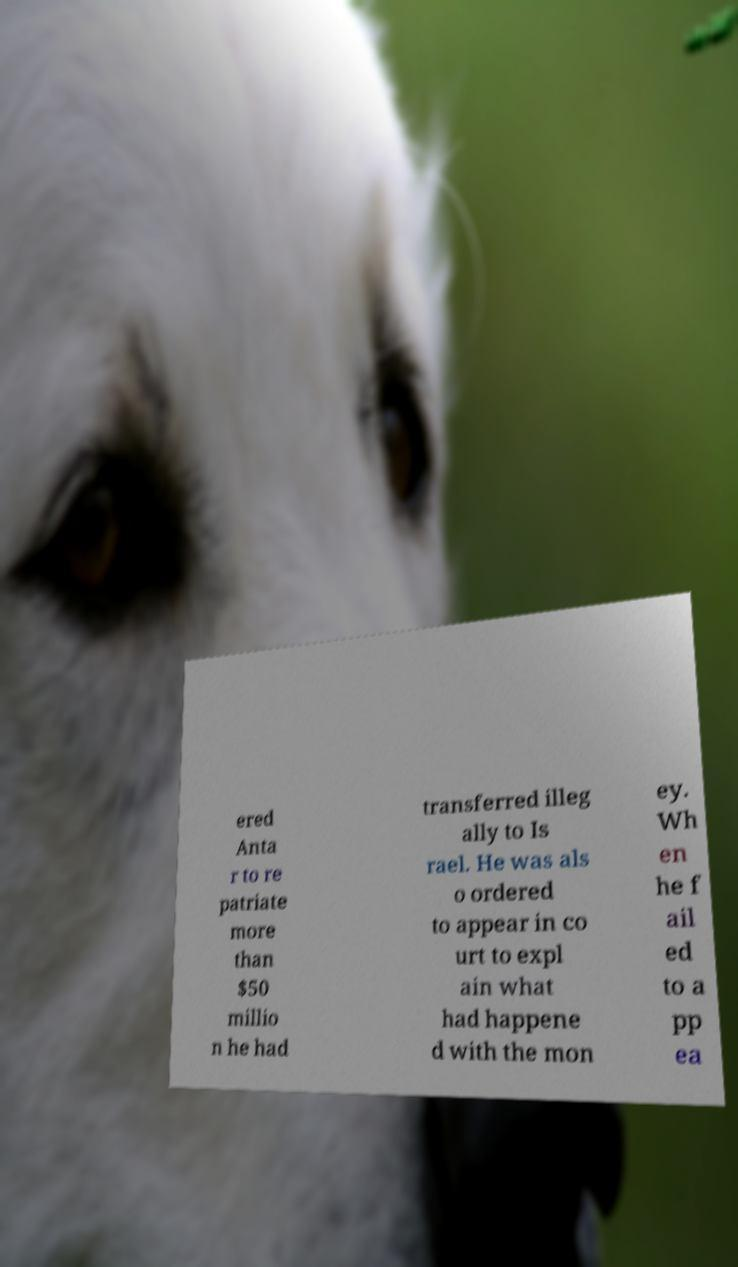Please read and relay the text visible in this image. What does it say? ered Anta r to re patriate more than $50 millio n he had transferred illeg ally to Is rael. He was als o ordered to appear in co urt to expl ain what had happene d with the mon ey. Wh en he f ail ed to a pp ea 